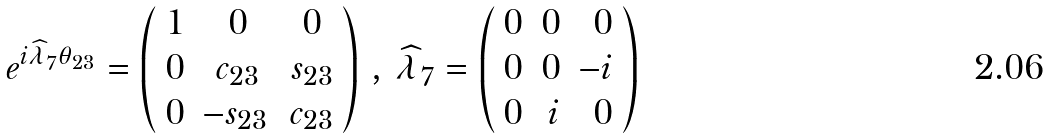Convert formula to latex. <formula><loc_0><loc_0><loc_500><loc_500>e ^ { i \widehat { \lambda } _ { 7 } \theta _ { 2 3 } } = \left ( \begin{array} { r c c } 1 & 0 & 0 \\ 0 & c _ { 2 3 } & s _ { 2 3 } \\ 0 & - s _ { 2 3 } \, & c _ { 2 3 } \end{array} \right ) \, , \, \widehat { \lambda } _ { 7 } = \left ( \begin{array} { r r r } 0 & 0 & 0 \\ 0 & 0 & - i \\ 0 & i & 0 \end{array} \right )</formula> 